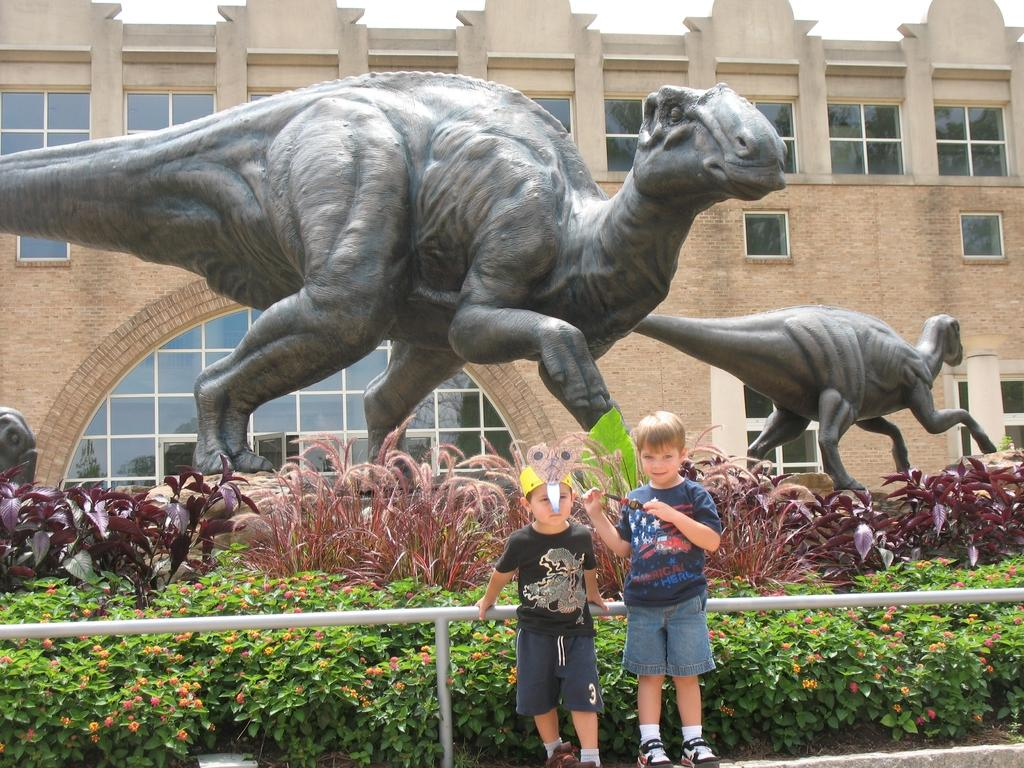How many kids are visible in the image? There are two kids standing in the image. What is located behind the kids? There is a fence behind the kids. What can be seen in the background of the image? There are plants, dinosaur statues, and a building in the background of the image. What type of lace is being used to decorate the pizzas in the image? There are no pizzas present in the image, so there is no lace being used to decorate them. 